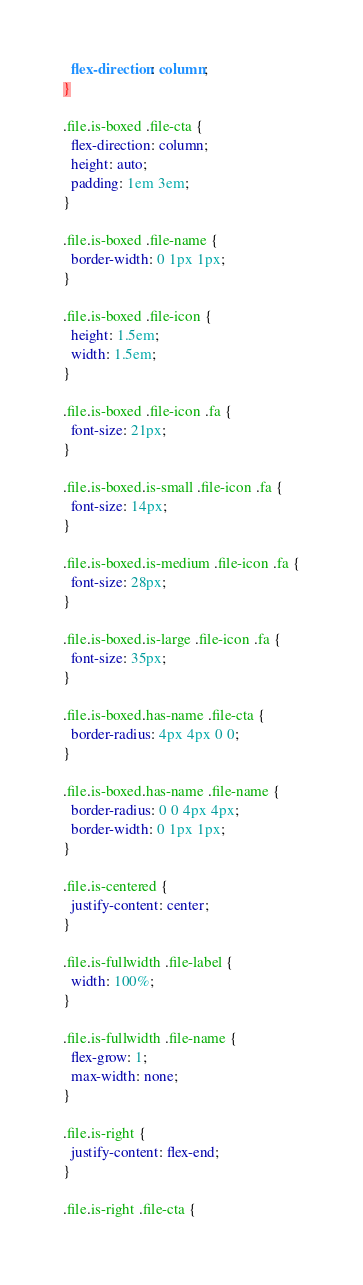Convert code to text. <code><loc_0><loc_0><loc_500><loc_500><_CSS_>  flex-direction: column;
}

.file.is-boxed .file-cta {
  flex-direction: column;
  height: auto;
  padding: 1em 3em;
}

.file.is-boxed .file-name {
  border-width: 0 1px 1px;
}

.file.is-boxed .file-icon {
  height: 1.5em;
  width: 1.5em;
}

.file.is-boxed .file-icon .fa {
  font-size: 21px;
}

.file.is-boxed.is-small .file-icon .fa {
  font-size: 14px;
}

.file.is-boxed.is-medium .file-icon .fa {
  font-size: 28px;
}

.file.is-boxed.is-large .file-icon .fa {
  font-size: 35px;
}

.file.is-boxed.has-name .file-cta {
  border-radius: 4px 4px 0 0;
}

.file.is-boxed.has-name .file-name {
  border-radius: 0 0 4px 4px;
  border-width: 0 1px 1px;
}

.file.is-centered {
  justify-content: center;
}

.file.is-fullwidth .file-label {
  width: 100%;
}

.file.is-fullwidth .file-name {
  flex-grow: 1;
  max-width: none;
}

.file.is-right {
  justify-content: flex-end;
}

.file.is-right .file-cta {</code> 